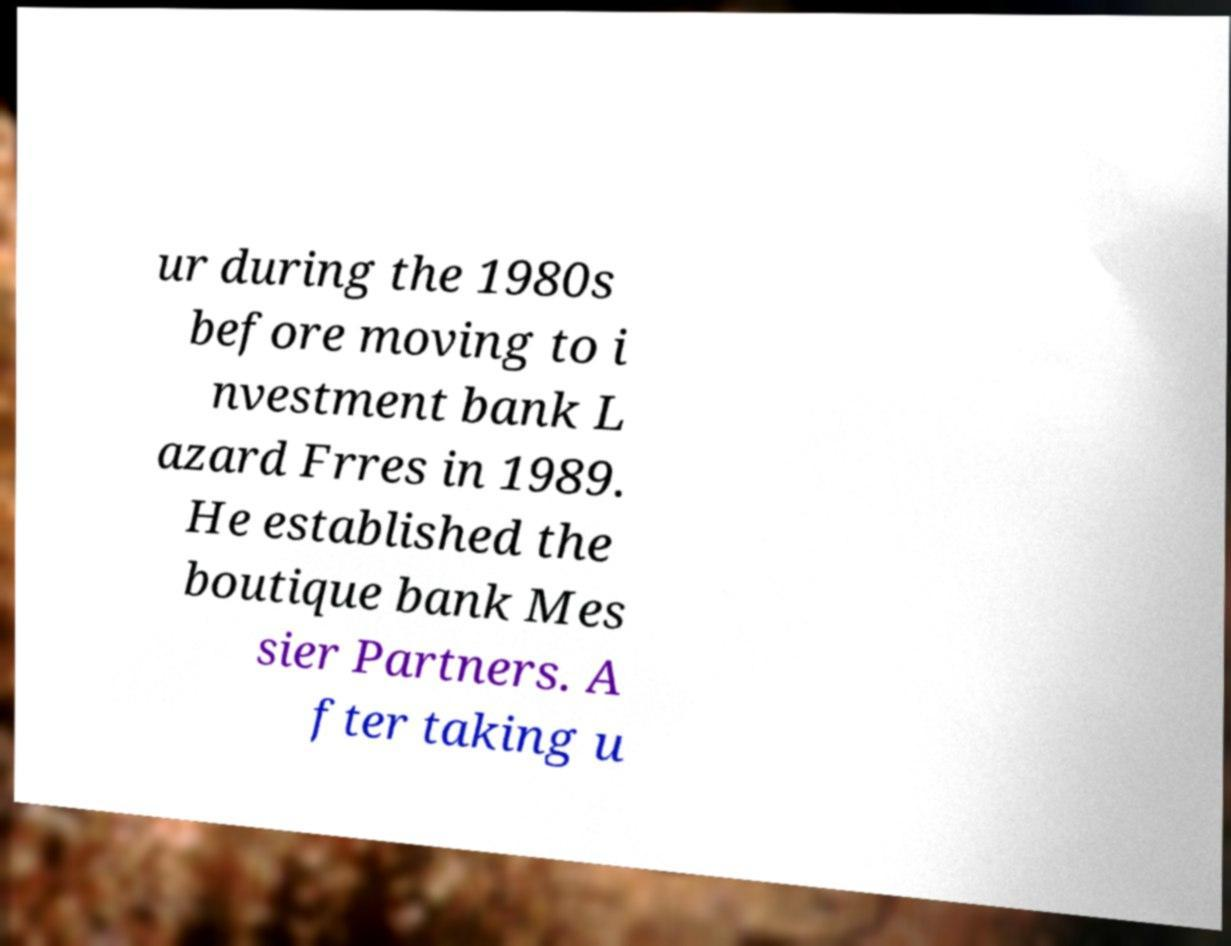For documentation purposes, I need the text within this image transcribed. Could you provide that? ur during the 1980s before moving to i nvestment bank L azard Frres in 1989. He established the boutique bank Mes sier Partners. A fter taking u 